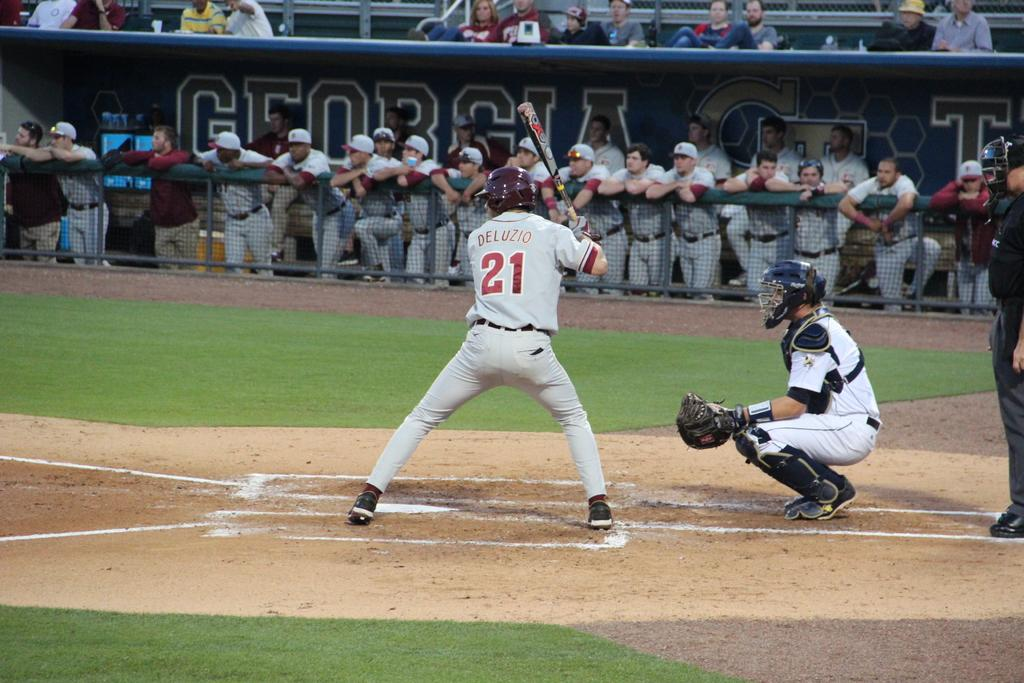<image>
Describe the image concisely. Player number 21 is taking his turn at bat. 